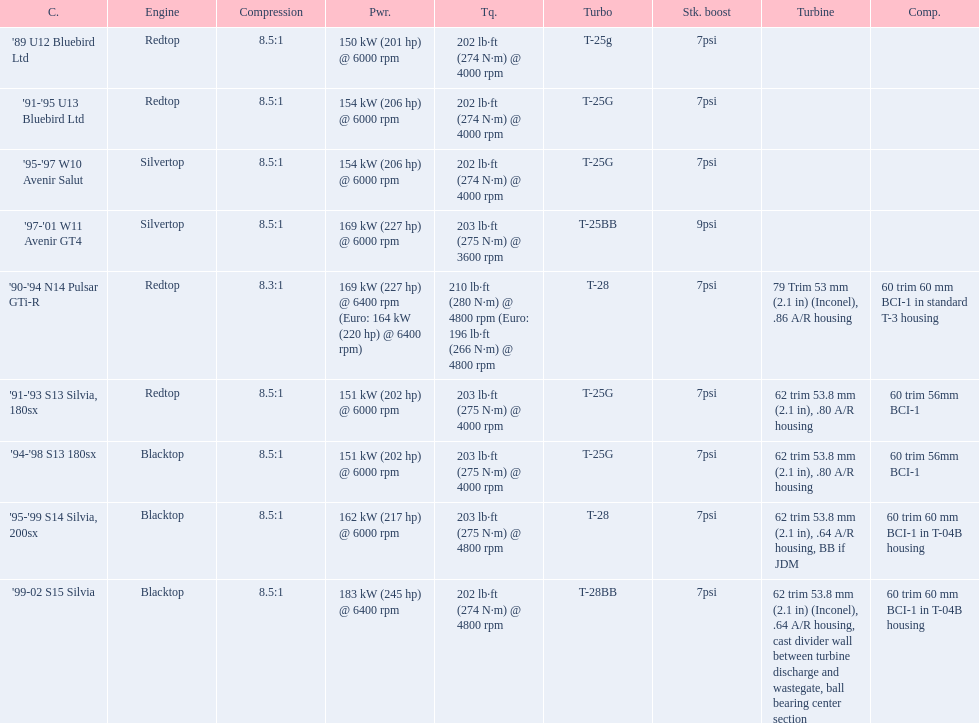What are all of the nissan cars? '89 U12 Bluebird Ltd, '91-'95 U13 Bluebird Ltd, '95-'97 W10 Avenir Salut, '97-'01 W11 Avenir GT4, '90-'94 N14 Pulsar GTi-R, '91-'93 S13 Silvia, 180sx, '94-'98 S13 180sx, '95-'99 S14 Silvia, 200sx, '99-02 S15 Silvia. Of these cars, which one is a '90-'94 n14 pulsar gti-r? '90-'94 N14 Pulsar GTi-R. What is the compression of this car? 8.3:1. 